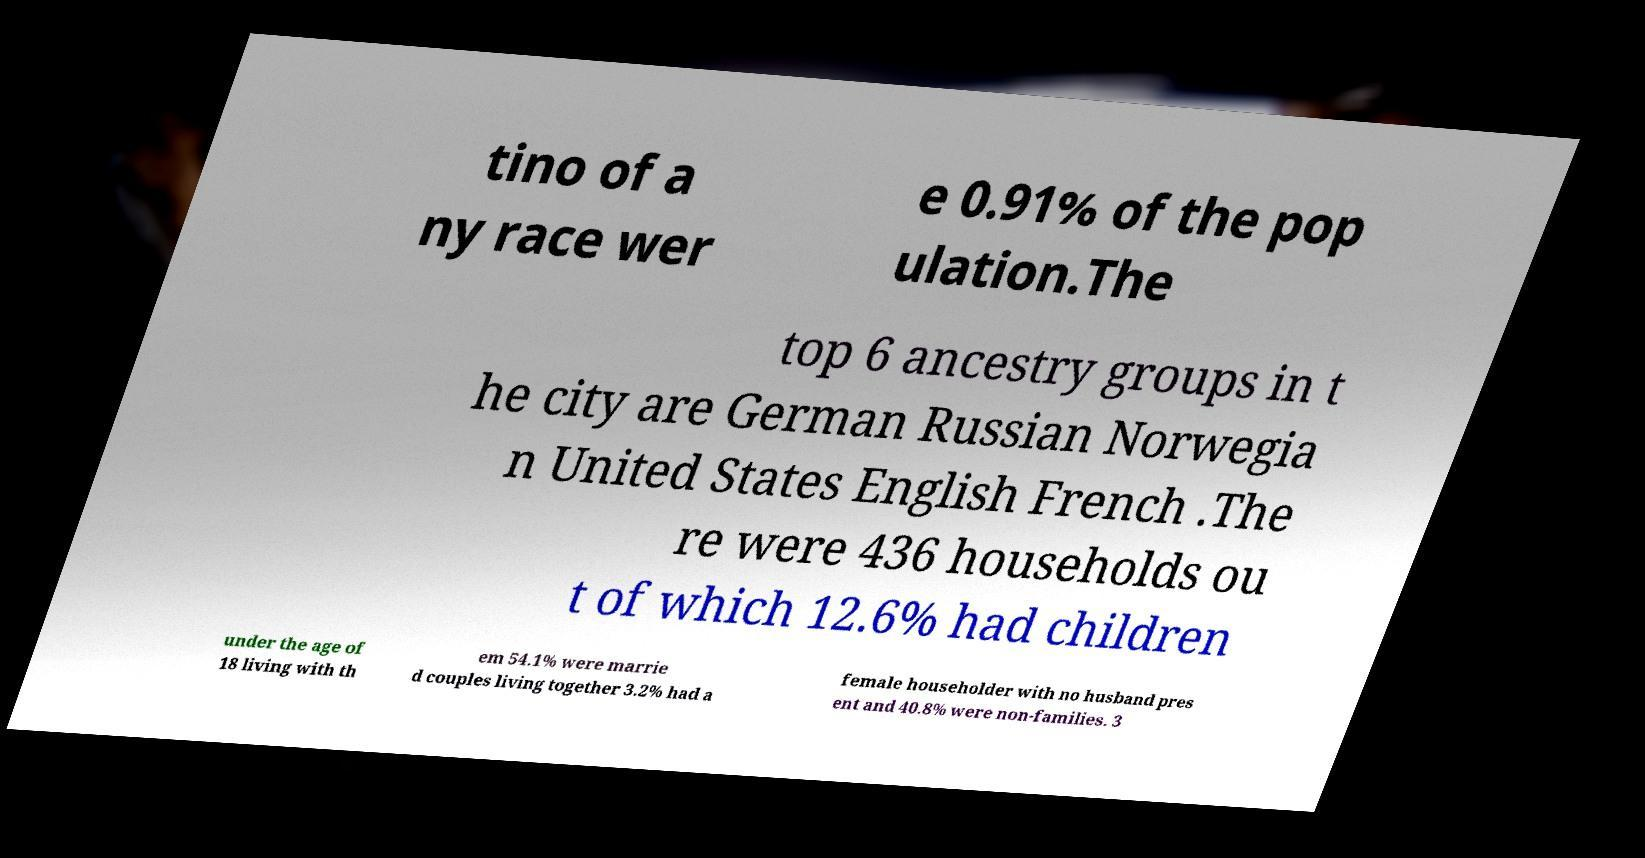For documentation purposes, I need the text within this image transcribed. Could you provide that? tino of a ny race wer e 0.91% of the pop ulation.The top 6 ancestry groups in t he city are German Russian Norwegia n United States English French .The re were 436 households ou t of which 12.6% had children under the age of 18 living with th em 54.1% were marrie d couples living together 3.2% had a female householder with no husband pres ent and 40.8% were non-families. 3 